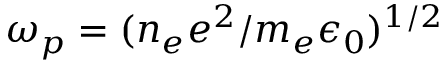Convert formula to latex. <formula><loc_0><loc_0><loc_500><loc_500>\omega _ { p } = ( n _ { e } e ^ { 2 } / m _ { e } \epsilon _ { 0 } ) ^ { 1 / 2 }</formula> 